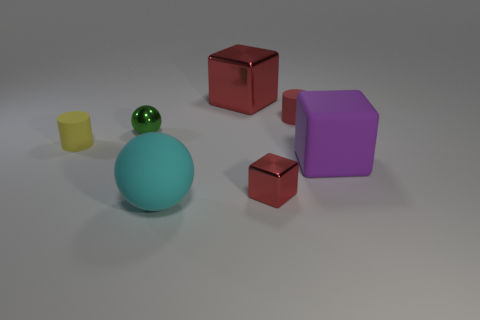The metallic object that is both right of the tiny ball and in front of the small red matte cylinder has what shape?
Ensure brevity in your answer.  Cube. Do the large metal object and the tiny cube have the same color?
Keep it short and to the point. Yes. How many small yellow objects are to the left of the metal cube that is behind the big matte thing behind the tiny red metal cube?
Ensure brevity in your answer.  1. There is a small green object that is made of the same material as the big red block; what is its shape?
Your response must be concise. Sphere. What is the material of the red thing that is in front of the cylinder behind the cylinder that is left of the green sphere?
Provide a short and direct response. Metal. What number of objects are either shiny blocks that are in front of the tiny green shiny sphere or tiny red matte cylinders?
Give a very brief answer. 2. What number of other things are the same shape as the tiny red rubber object?
Your answer should be very brief. 1. Are there more tiny red blocks that are in front of the shiny sphere than large purple matte objects?
Ensure brevity in your answer.  No. The other rubber thing that is the same shape as the tiny yellow thing is what size?
Your answer should be very brief. Small. Is there any other thing that is made of the same material as the big red cube?
Offer a terse response. Yes. 